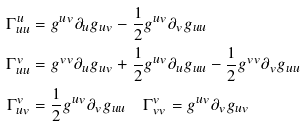Convert formula to latex. <formula><loc_0><loc_0><loc_500><loc_500>\Gamma ^ { u } _ { u u } & = g ^ { u v } \partial _ { u } g _ { u v } - \frac { 1 } { 2 } g ^ { u v } \partial _ { v } g _ { u u } \\ \Gamma ^ { v } _ { u u } & = g ^ { v v } \partial _ { u } g _ { u v } + \frac { 1 } { 2 } g ^ { u v } \partial _ { u } g _ { u u } - \frac { 1 } { 2 } g ^ { v v } \partial _ { v } g _ { u u } \\ \Gamma ^ { v } _ { u v } & = \frac { 1 } { 2 } g ^ { u v } \partial _ { v } g _ { u u } \quad \Gamma ^ { v } _ { v v } = g ^ { u v } \partial _ { v } g _ { u v }</formula> 